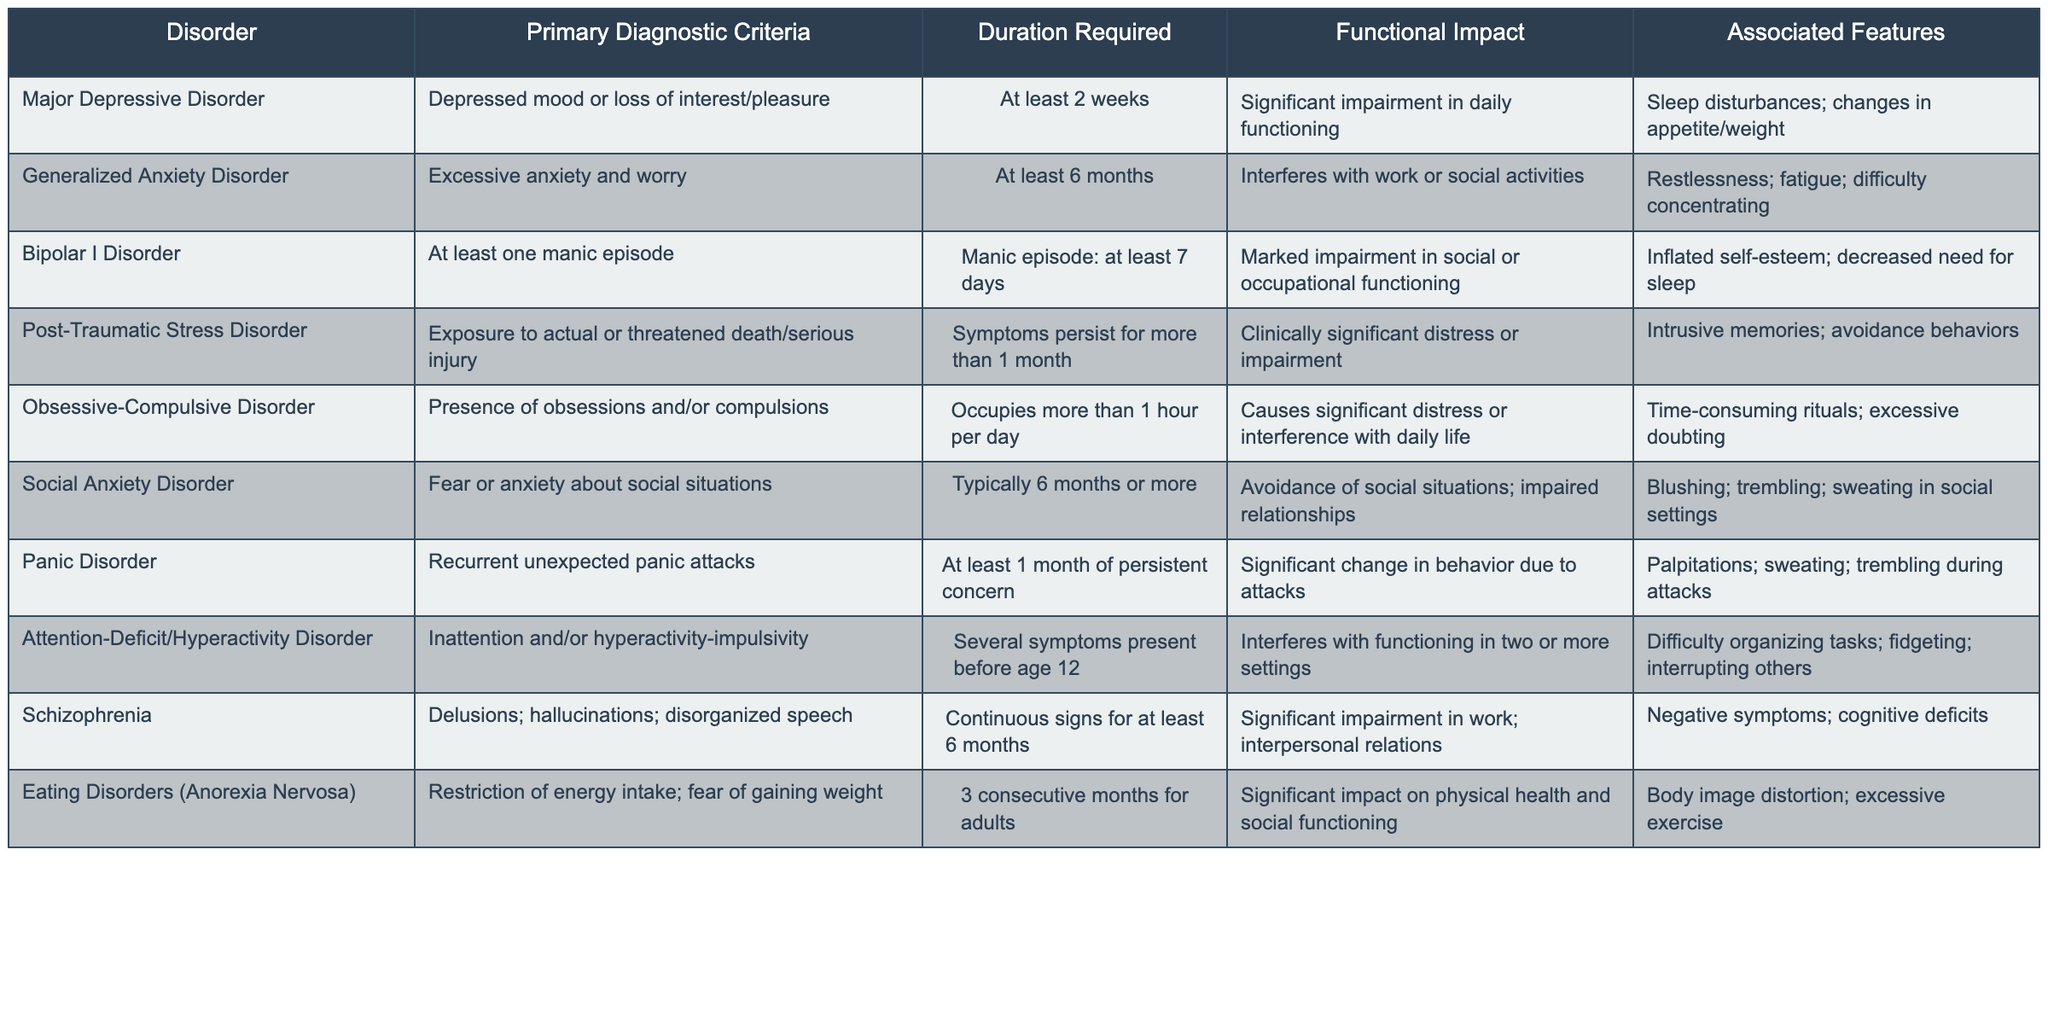What is the primary diagnostic criterion for Major Depressive Disorder? According to the table, the primary diagnostic criterion for Major Depressive Disorder is "Depressed mood or loss of interest/pleasure."
Answer: Depressed mood or loss of interest/pleasure How long must symptoms persist for a diagnosis of Generalized Anxiety Disorder? The table indicates that symptoms must persist for at least 6 months for a diagnosis of Generalized Anxiety Disorder.
Answer: At least 6 months Which disorder requires that symptoms persist for at least 1 month? The table states that Post-Traumatic Stress Disorder requires symptoms to persist for more than 1 month.
Answer: Post-Traumatic Stress Disorder Does Bipolar I Disorder require significant impairment in social or occupational functioning? Yes, according to the table, Bipolar I Disorder is characterized by "Marked impairment in social or occupational functioning."
Answer: Yes What is the associated feature common to Panic Disorder? The table lists "Palpitations; sweating; trembling during attacks" as an associated feature of Panic Disorder.
Answer: Palpitations; sweating; trembling during attacks Which disorder has a duration requirement of 3 consecutive months for adults? The table indicates that Eating Disorders (Anorexia Nervosa) have a duration requirement of 3 consecutive months for adults.
Answer: Eating Disorders (Anorexia Nervosa) What is the functional impact of Social Anxiety Disorder? The table notes that Social Anxiety Disorder results in avoidance of social situations and impaired relationships, indicating a significant functional impact.
Answer: Avoidance of social situations; impaired relationships Compare the duration requirements for Panic Disorder and Generalized Anxiety Disorder. Panic Disorder requires at least 1 month of persistent concern, while Generalized Anxiety Disorder requires at least 6 months of symptoms. The latter has a longer duration requirement.
Answer: Generalized Anxiety Disorder requires a longer duration Which disorders involve significant distress or impairment according to their functional impacts? The table lists Major Depressive Disorder, Obsessive-Compulsive Disorder, Post-Traumatic Stress Disorder, and Social Anxiety Disorder as having significant distress or impairment in their functional impacts.
Answer: Major Depressive Disorder, Obsessive-Compulsive Disorder, Post-Traumatic Stress Disorder, Social Anxiety Disorder How many disorders listed are characterized by the presence of anxiety or worry? The table lists Generalized Anxiety Disorder, Social Anxiety Disorder, and Panic Disorder as characterized by anxiety or worry. Therefore, there are three such disorders.
Answer: Three disorders What is the average required duration for the disorders listed? The durations in the table are: 2 weeks, 6 months, 7 days, 1 month, >1 hour/day, 6 months, 1 month, before age 12, 6 months, 3 months. Converting them to days gives us: 14, 180, 7, 30, 1, 180, 30, 3655 (approx. for before age 12), 180, 90. The total is 4163 days among 10 disorders, giving an average of 416.3 days.
Answer: Approximately 416.3 days 